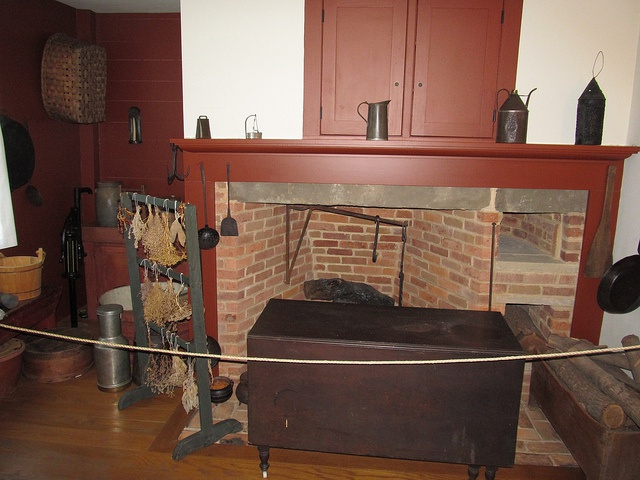Describe the objects in this image and their specific colors. I can see bottle in black and gray tones, bench in black, maroon, olive, and tan tones, and spoon in black, maroon, and gray tones in this image. 